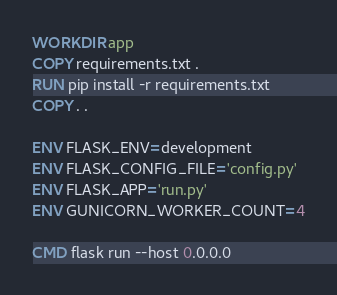Convert code to text. <code><loc_0><loc_0><loc_500><loc_500><_Dockerfile_>WORKDIR app
COPY requirements.txt .
RUN pip install -r requirements.txt
COPY . .

ENV FLASK_ENV=development
ENV FLASK_CONFIG_FILE='config.py'
ENV FLASK_APP='run.py'
ENV GUNICORN_WORKER_COUNT=4

CMD flask run --host 0.0.0.0
</code> 